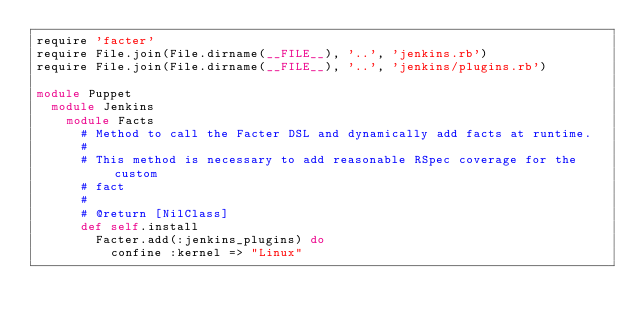Convert code to text. <code><loc_0><loc_0><loc_500><loc_500><_Ruby_>require 'facter'
require File.join(File.dirname(__FILE__), '..', 'jenkins.rb')
require File.join(File.dirname(__FILE__), '..', 'jenkins/plugins.rb')

module Puppet
  module Jenkins
    module Facts
      # Method to call the Facter DSL and dynamically add facts at runtime.
      #
      # This method is necessary to add reasonable RSpec coverage for the custom
      # fact
      #
      # @return [NilClass]
      def self.install
        Facter.add(:jenkins_plugins) do
          confine :kernel => "Linux"</code> 